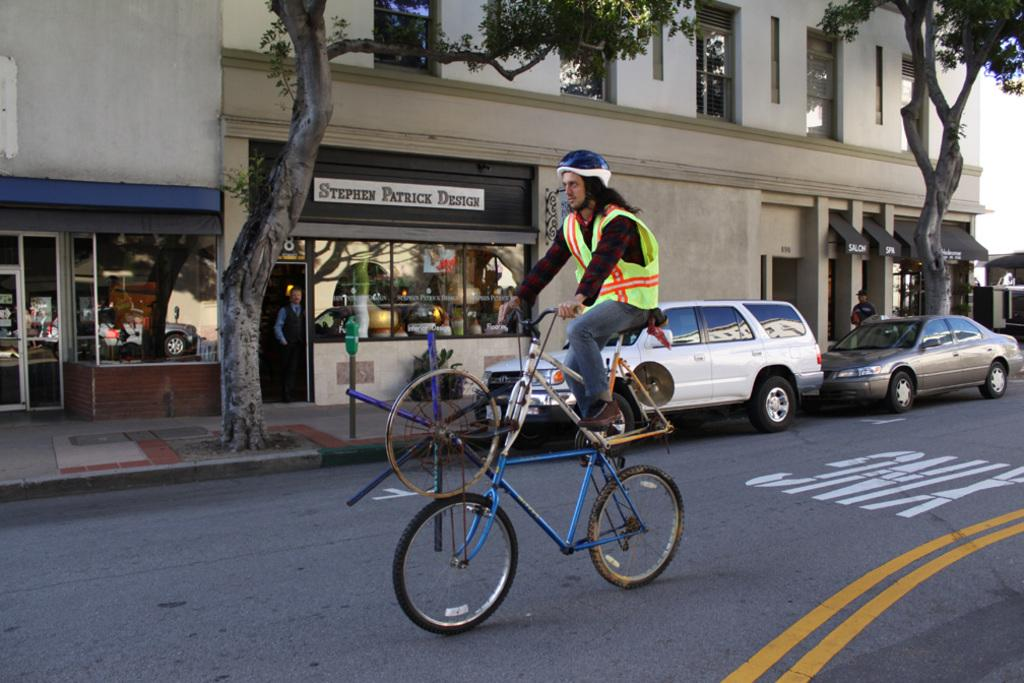What is the person in the image doing? The person is sitting on a bicycle in the image. What can be seen in the background of the image? There are buildings, trees, vehicles, and people in the background of the image. What part of the sky is visible in the image? The sky is visible on the right side of the image. How many snakes are crawling in the person's pocket in the image? There are no snakes present in the image, and the person's pocket is not visible. What question is being asked by the person on the bicycle in the image? There is no indication in the image that the person is asking a question. 